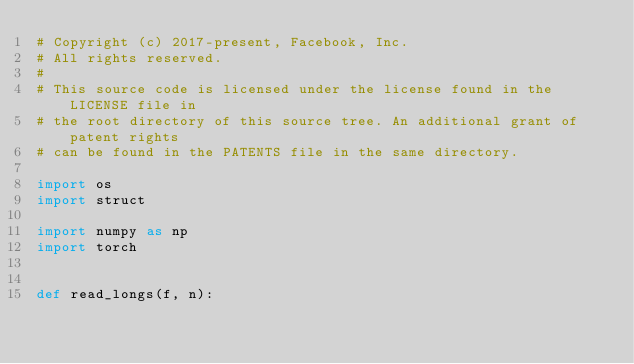Convert code to text. <code><loc_0><loc_0><loc_500><loc_500><_Python_># Copyright (c) 2017-present, Facebook, Inc.
# All rights reserved.
#
# This source code is licensed under the license found in the LICENSE file in
# the root directory of this source tree. An additional grant of patent rights
# can be found in the PATENTS file in the same directory.

import os
import struct

import numpy as np
import torch


def read_longs(f, n):</code> 